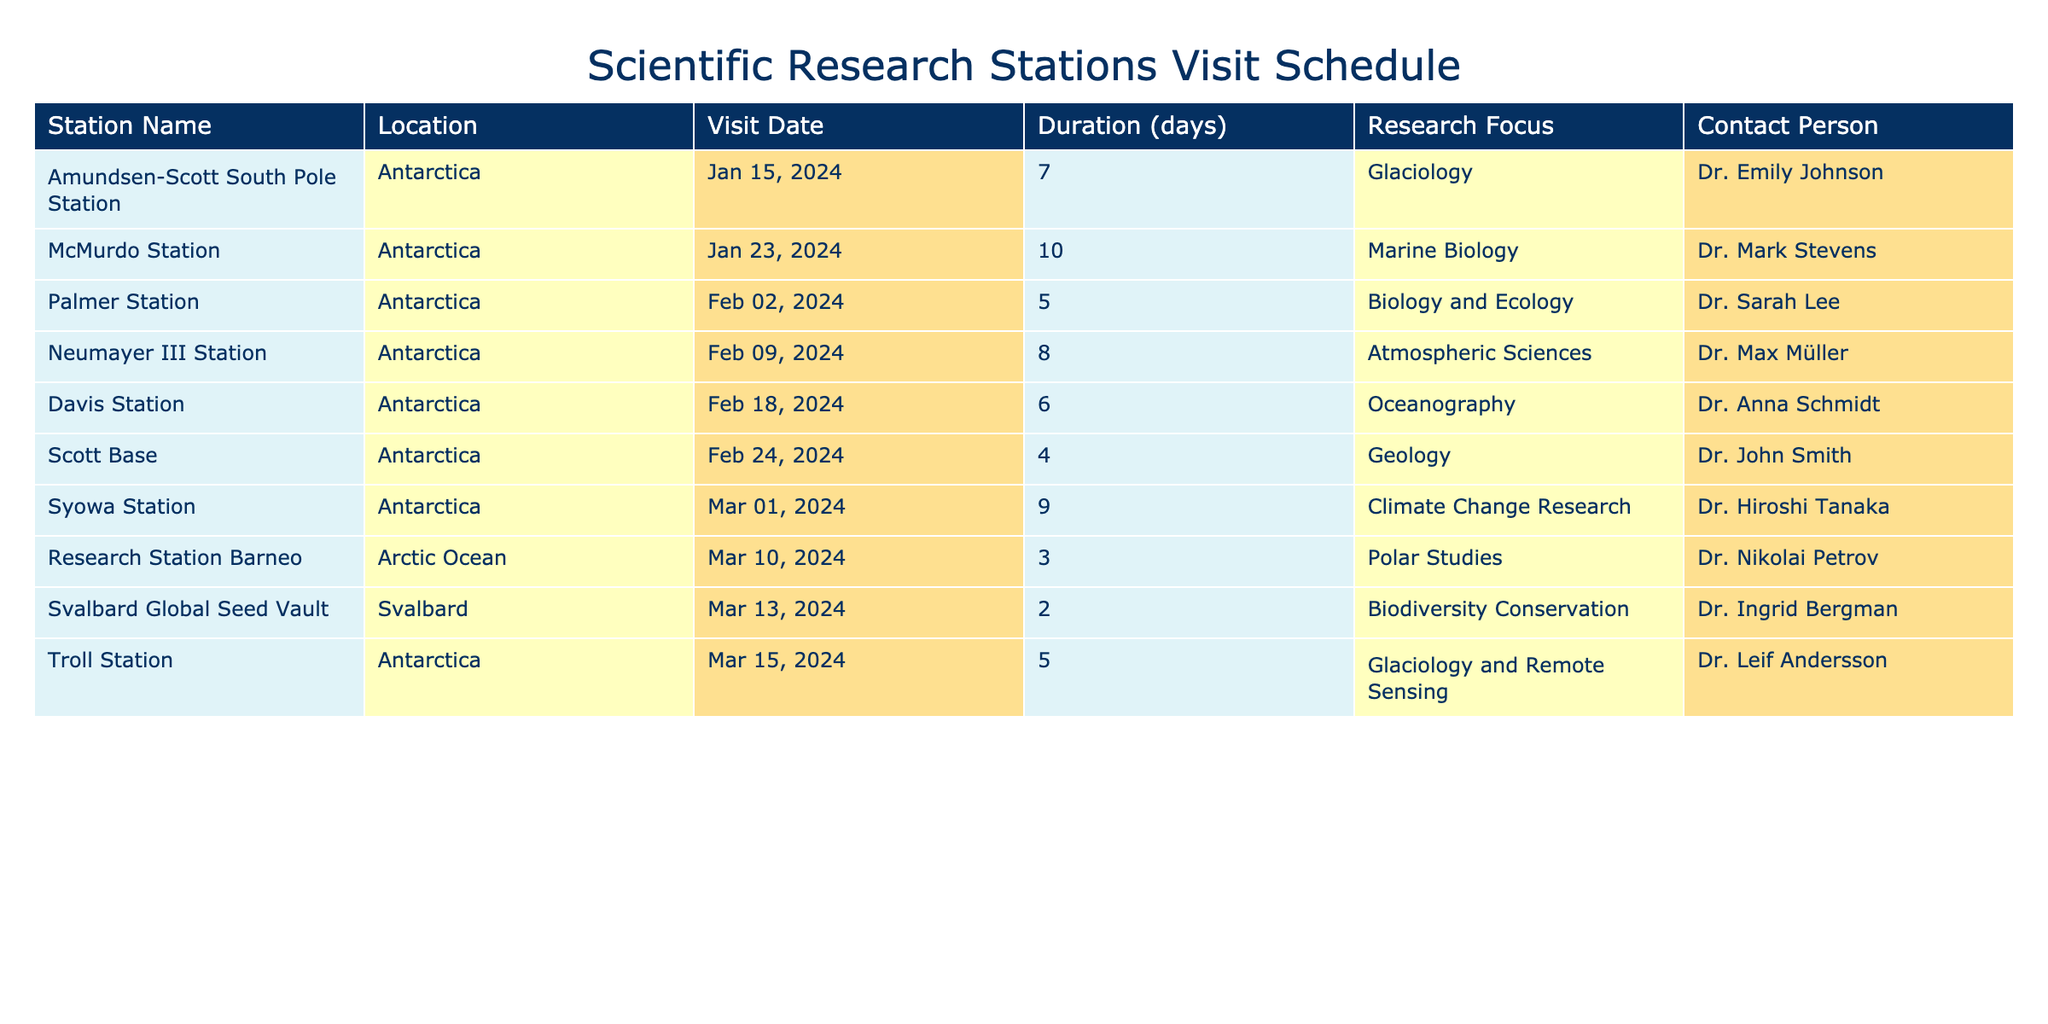What is the research focus of McMurdo Station? McMurdo Station's research focus is listed in the "Research Focus" column of the table. According to that column, the focus for McMurdo Station is Marine Biology.
Answer: Marine Biology When is the visit to Palmer Station scheduled? The visit date for Palmer Station is found in the "Visit Date" column. It shows that the scheduled visit is on February 2, 2024.
Answer: February 2, 2024 Which station has the longest duration of stay? To find the station with the longest duration, we need to compare the "Duration (days)" column. The longest duration is 10 days, which corresponds to McMurdo Station.
Answer: McMurdo Station How many days will be spent in total at all Antarctic stations? We will sum the "Duration (days)" of all the Antarctic stations listed in the table: 7 (Amundsen-Scott) + 10 (McMurdo) + 5 (Palmer) + 8 (Neumayer III) + 6 (Davis) + 4 (Scott Base) + 9 (Syowa) + 5 (Troll) = 54 days total spent at Antarctic stations.
Answer: 54 days Is there a research focus on oceanography at any of the stations? Looking through the "Research Focus" column, we see Davis Station has Oceanography listed as its research focus. Therefore, there is an oceanography focus at one of the stations.
Answer: Yes Which research station visit is scheduled immediately after McMurdo Station? By checking the "Visit Date" column, McMurdo's visit ends on February 2, 2024. The next visit listed is to Palmer Station, which starts on the same day, February 2, 2024.
Answer: Palmer Station Are there any stations focused on biodiversity conservation? Reviewing the "Research Focus" column, Svalbard Global Seed Vault is identified as having Biodiversity Conservation as its focus, making it a station with this research theme.
Answer: Yes What is the average duration of the visits to all research stations? To find the average duration, we calculate the sum of all durations, which is 7 + 10 + 5 + 8 + 6 + 4 + 9 + 3 + 2 + 5 = 59 days. This is then divided by the number of stations (10): 59 / 10 = 5.9 days.
Answer: 5.9 days 